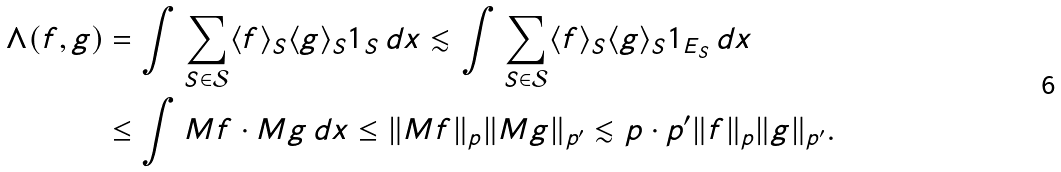<formula> <loc_0><loc_0><loc_500><loc_500>\Lambda ( f , g ) & = \int \sum _ { S \in \mathcal { S } } \langle f \rangle _ { S } \langle g \rangle _ { S } \mathbf 1 _ { S } \, d x \lesssim \int \sum _ { S \in \mathcal { S } } \langle f \rangle _ { S } \langle g \rangle _ { S } \mathbf 1 _ { E _ { S } } \, d x \\ & \leq \int M f \cdot M g \, d x \leq \| M f \| _ { p } \| M g \| _ { p ^ { \prime } } \lesssim p \cdot p ^ { \prime } \| f \| _ { p } \| g \| _ { p ^ { \prime } } .</formula> 